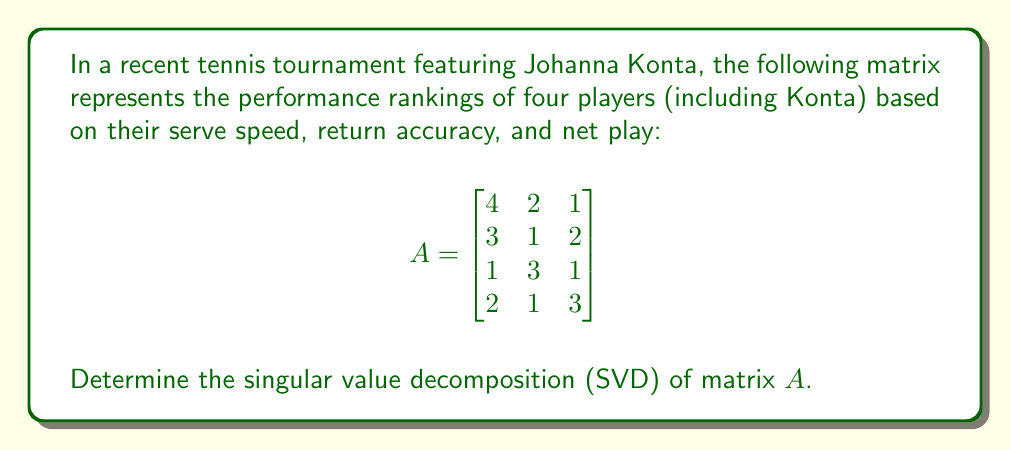Provide a solution to this math problem. To find the singular value decomposition of matrix $A$, we need to follow these steps:

1) First, calculate $A^TA$:
   $$A^TA = \begin{bmatrix}
   4 & 3 & 1 & 2 \\
   2 & 1 & 3 & 1 \\
   1 & 2 & 1 & 3
   \end{bmatrix} \begin{bmatrix}
   4 & 2 & 1 \\
   3 & 1 & 2 \\
   1 & 3 & 1 \\
   2 & 1 & 3
   \end{bmatrix} = \begin{bmatrix}
   30 & 15 & 17 \\
   15 & 15 & 9 \\
   17 & 9 & 15
   \end{bmatrix}$$

2) Find the eigenvalues of $A^TA$ by solving $\det(A^TA - \lambda I) = 0$:
   $$\det\begin{bmatrix}
   30-\lambda & 15 & 17 \\
   15 & 15-\lambda & 9 \\
   17 & 9 & 15-\lambda
   \end{bmatrix} = 0$$

   This yields the characteristic equation:
   $-\lambda^3 + 60\lambda^2 - 675\lambda + 900 = 0$

   Solving this equation gives us:
   $\lambda_1 \approx 50.52$, $\lambda_2 \approx 8.48$, $\lambda_3 \approx 1$

3) The singular values are the square roots of these eigenvalues:
   $\sigma_1 \approx 7.11$, $\sigma_2 \approx 2.91$, $\sigma_3 = 1$

4) To find the right singular vectors, we solve $(A^TA - \lambda_i I)v_i = 0$ for each $\lambda_i$:
   
   For $\lambda_1$: $v_1 \approx [0.707, 0.408, 0.577]^T$
   For $\lambda_2$: $v_2 \approx [-0.707, 0.707, 0]^T$
   For $\lambda_3$: $v_3 \approx [0, -0.577, 0.816]^T$

5) The left singular vectors are given by $u_i = \frac{1}{\sigma_i}Av_i$:
   
   $u_1 \approx [0.620, 0.507, 0.388, 0.453]^T$
   $u_2 \approx [-0.284, -0.452, 0.776, -0.341]^T$
   $u_3 \approx [0.426, -0.630, 0.197, -0.615]^T$

6) The SVD of $A$ is then given by $A = U\Sigma V^T$, where:

   $U = [u_1 \; u_2 \; u_3]$
   $\Sigma = \begin{bmatrix}
   7.11 & 0 & 0 \\
   0 & 2.91 & 0 \\
   0 & 0 & 1 \\
   0 & 0 & 0
   \end{bmatrix}$
   $V = [v_1 \; v_2 \; v_3]$
Answer: $A = U\Sigma V^T$, where $U \approx [0.620, -0.284, 0.426; 0.507, -0.452, -0.630; 0.388, 0.776, 0.197; 0.453, -0.341, -0.615]$, $\Sigma \approx \text{diag}(7.11, 2.91, 1, 0)$, and $V \approx [0.707, -0.707, 0; 0.408, 0.707, -0.577; 0.577, 0, 0.816]$. 